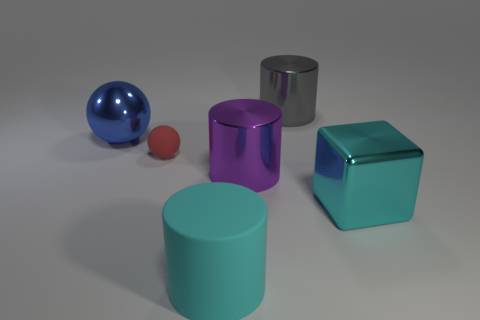How many cyan rubber things are to the right of the rubber cylinder? There are no cyan rubber items to the right of the silver metallic cylinder. The only cyan object present is a cylinder itself, which is not to the right but rather in the center of the arrangement. 